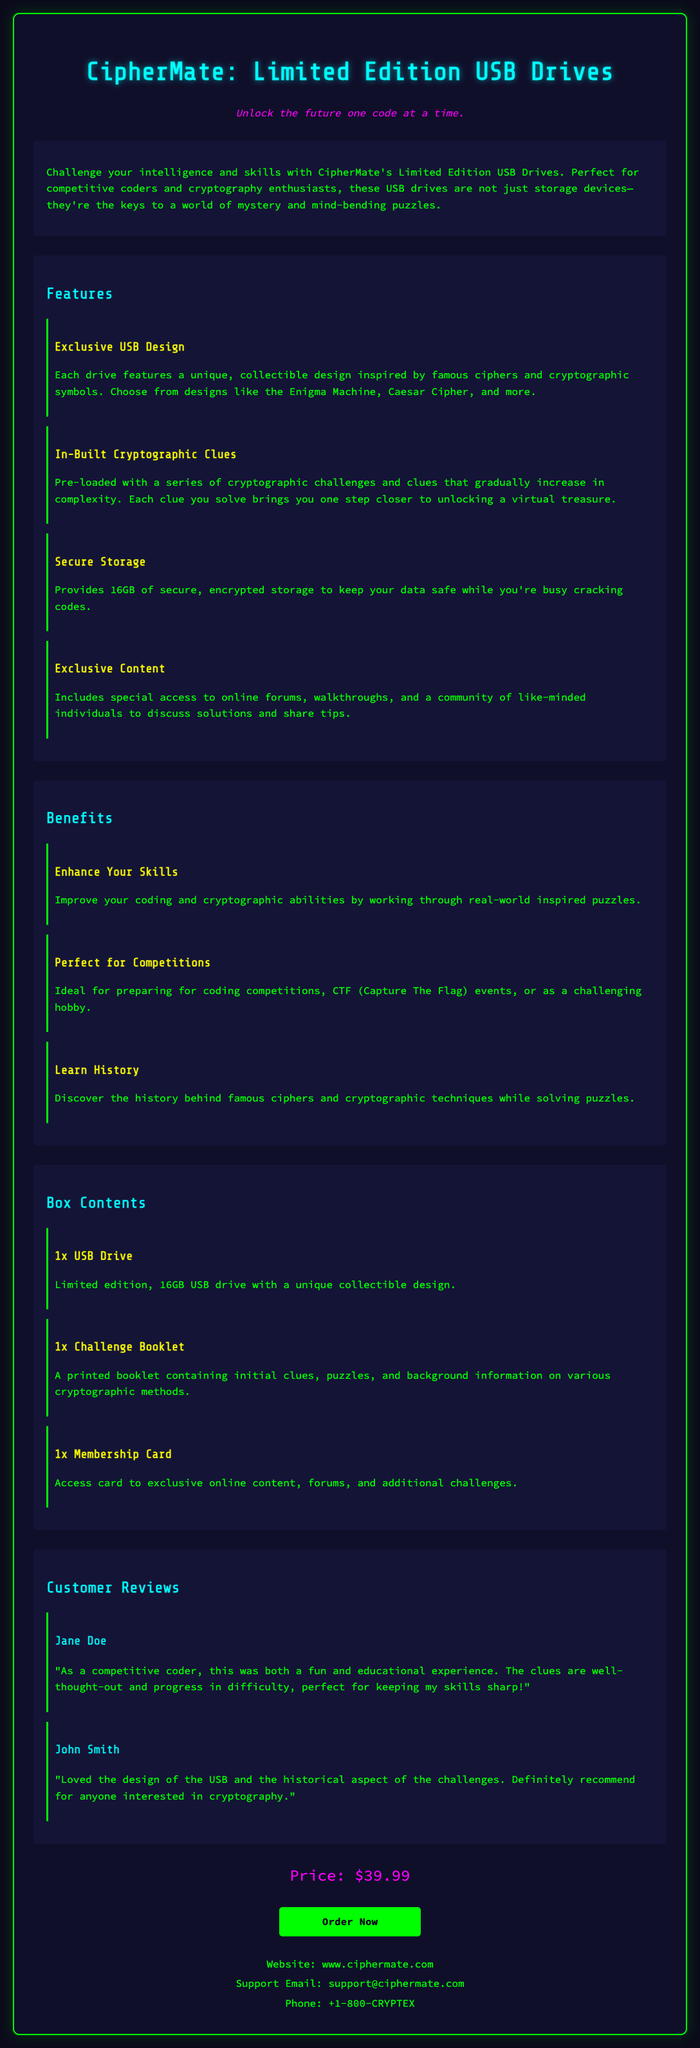what is the price of the USB drive? The document states the price of the USB drive as $39.99.
Answer: $39.99 how many gigabytes of storage does the USB drive provide? The USB drive provides 16GB of secure, encrypted storage.
Answer: 16GB what is the name of the product? The product name is "CipherMate: Limited Edition USB Drives".
Answer: CipherMate: Limited Edition USB Drives who is the intended audience for this USB drive? The USB drive is designed for competitive coders and cryptography enthusiasts.
Answer: competitive coders and cryptography enthusiasts what type of booklet is included in the box contents? The box includes a "Challenge Booklet" that contains clues, puzzles, and background information.
Answer: Challenge Booklet what is one benefit mentioned in the document? One of the benefits mentioned is that it enhances your coding and cryptographic skills.
Answer: Enhance Your Skills which cryptographic challenge design is NOT mentioned? No mention of the "RSA Algorithm" as part of the designs.
Answer: RSA Algorithm how many customer reviews are included in the document? There are two customer reviews provided in the document.
Answer: two what online resources do buyers receive access to? Buyers receive access to online forums and additional challenges.
Answer: online forums and additional challenges 